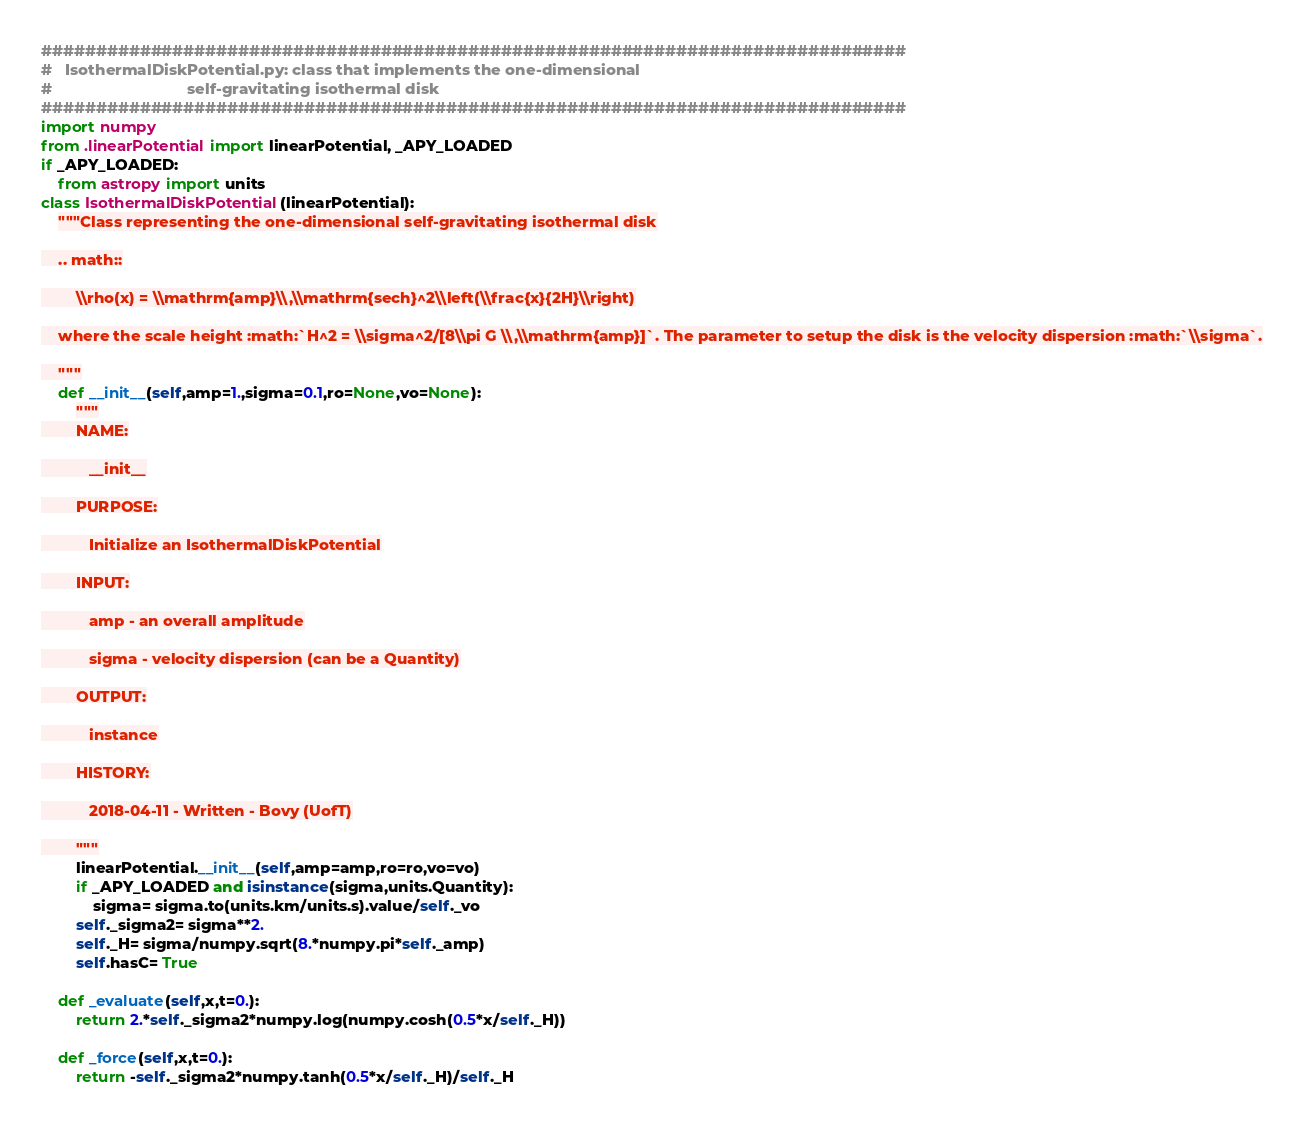<code> <loc_0><loc_0><loc_500><loc_500><_Python_>###############################################################################
#   IsothermalDiskPotential.py: class that implements the one-dimensional
#                               self-gravitating isothermal disk
###############################################################################
import numpy
from .linearPotential import linearPotential, _APY_LOADED
if _APY_LOADED:
    from astropy import units
class IsothermalDiskPotential(linearPotential):
    """Class representing the one-dimensional self-gravitating isothermal disk

    .. math::

        \\rho(x) = \\mathrm{amp}\\,\\mathrm{sech}^2\\left(\\frac{x}{2H}\\right)

    where the scale height :math:`H^2 = \\sigma^2/[8\\pi G \\,\\mathrm{amp}]`. The parameter to setup the disk is the velocity dispersion :math:`\\sigma`.

    """
    def __init__(self,amp=1.,sigma=0.1,ro=None,vo=None):
        """
        NAME:

           __init__

        PURPOSE:

           Initialize an IsothermalDiskPotential

        INPUT:

           amp - an overall amplitude

           sigma - velocity dispersion (can be a Quantity)

        OUTPUT:

           instance

        HISTORY:

           2018-04-11 - Written - Bovy (UofT)

        """
        linearPotential.__init__(self,amp=amp,ro=ro,vo=vo)
        if _APY_LOADED and isinstance(sigma,units.Quantity):
            sigma= sigma.to(units.km/units.s).value/self._vo
        self._sigma2= sigma**2.
        self._H= sigma/numpy.sqrt(8.*numpy.pi*self._amp)
        self.hasC= True
        
    def _evaluate(self,x,t=0.):
        return 2.*self._sigma2*numpy.log(numpy.cosh(0.5*x/self._H))

    def _force(self,x,t=0.):
        return -self._sigma2*numpy.tanh(0.5*x/self._H)/self._H
</code> 